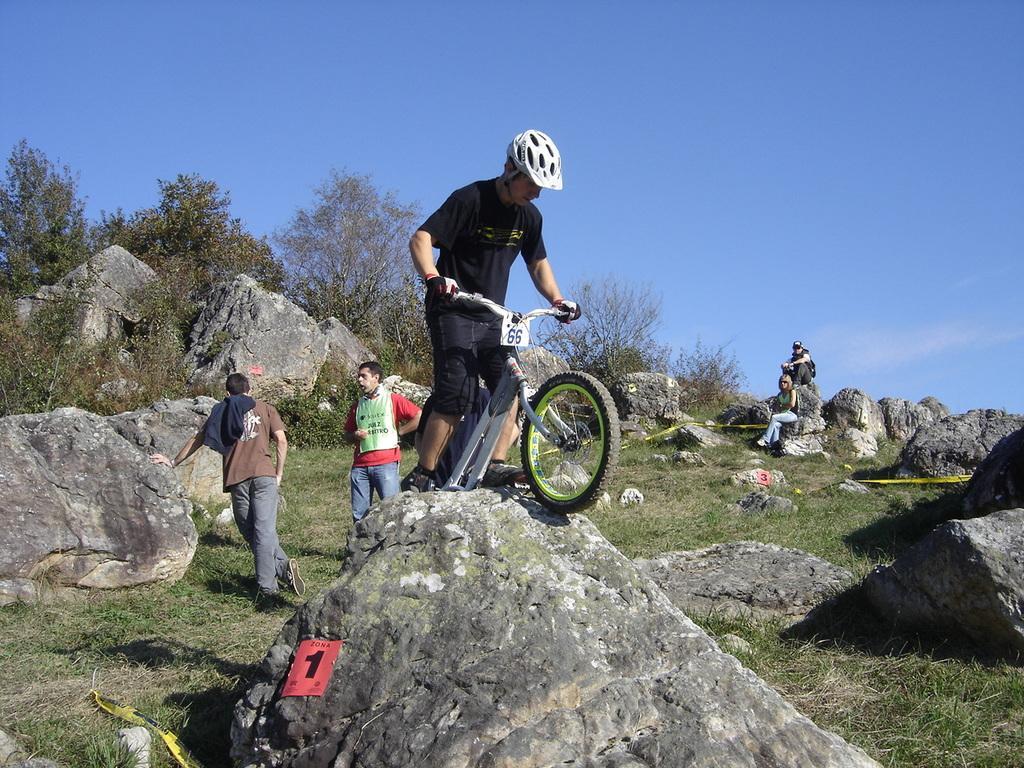In one or two sentences, can you explain what this image depicts? This is the picture outside of the city. There is a man riding the bicycle. At the back there are two persons standing behind the rock, at the back there are two persons sitting on the rock. At the top there is a sky, at the back there is a tree, at the bottom there is a grass and rocks. 